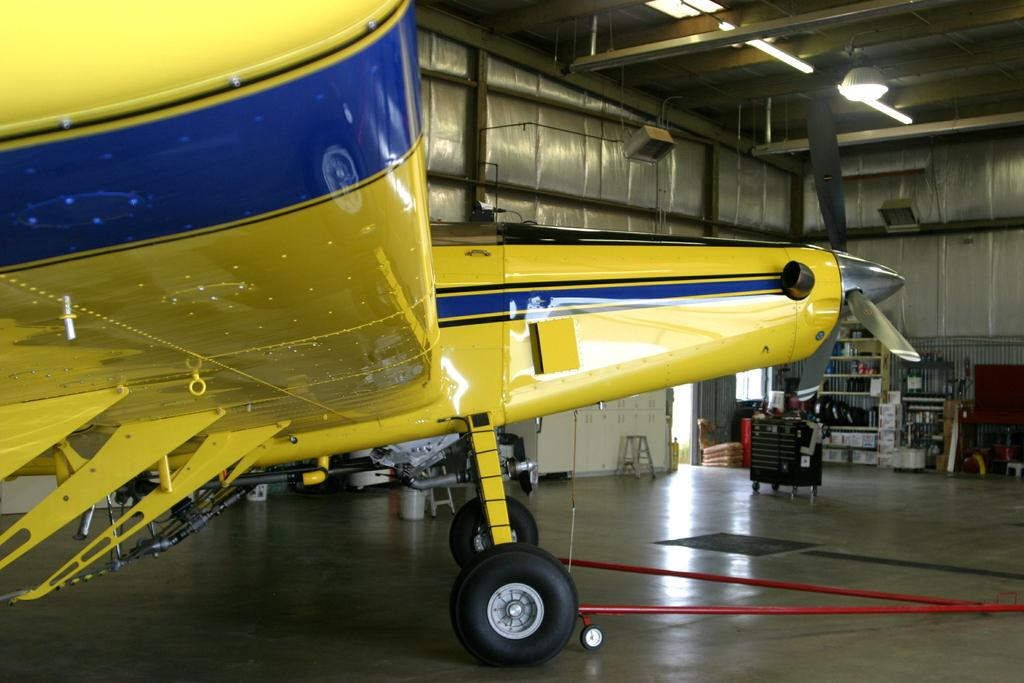What is placed on the floor in the image? There is a flight visible on the floor. What is at the top of the image? There is a roof at the top of the image. What can be used for storage in the image? There is a rack in the image that can be used for storage. What type of furniture is present for sitting? There are chairs in the image. What type of furniture is present for placing objects? There is a table in the image. Can you tell me how many grapes are on the table in the image? There are no grapes present in the image. What thoughts are being expressed by the chairs in the image? Chairs do not have thoughts, as they are inanimate objects. 